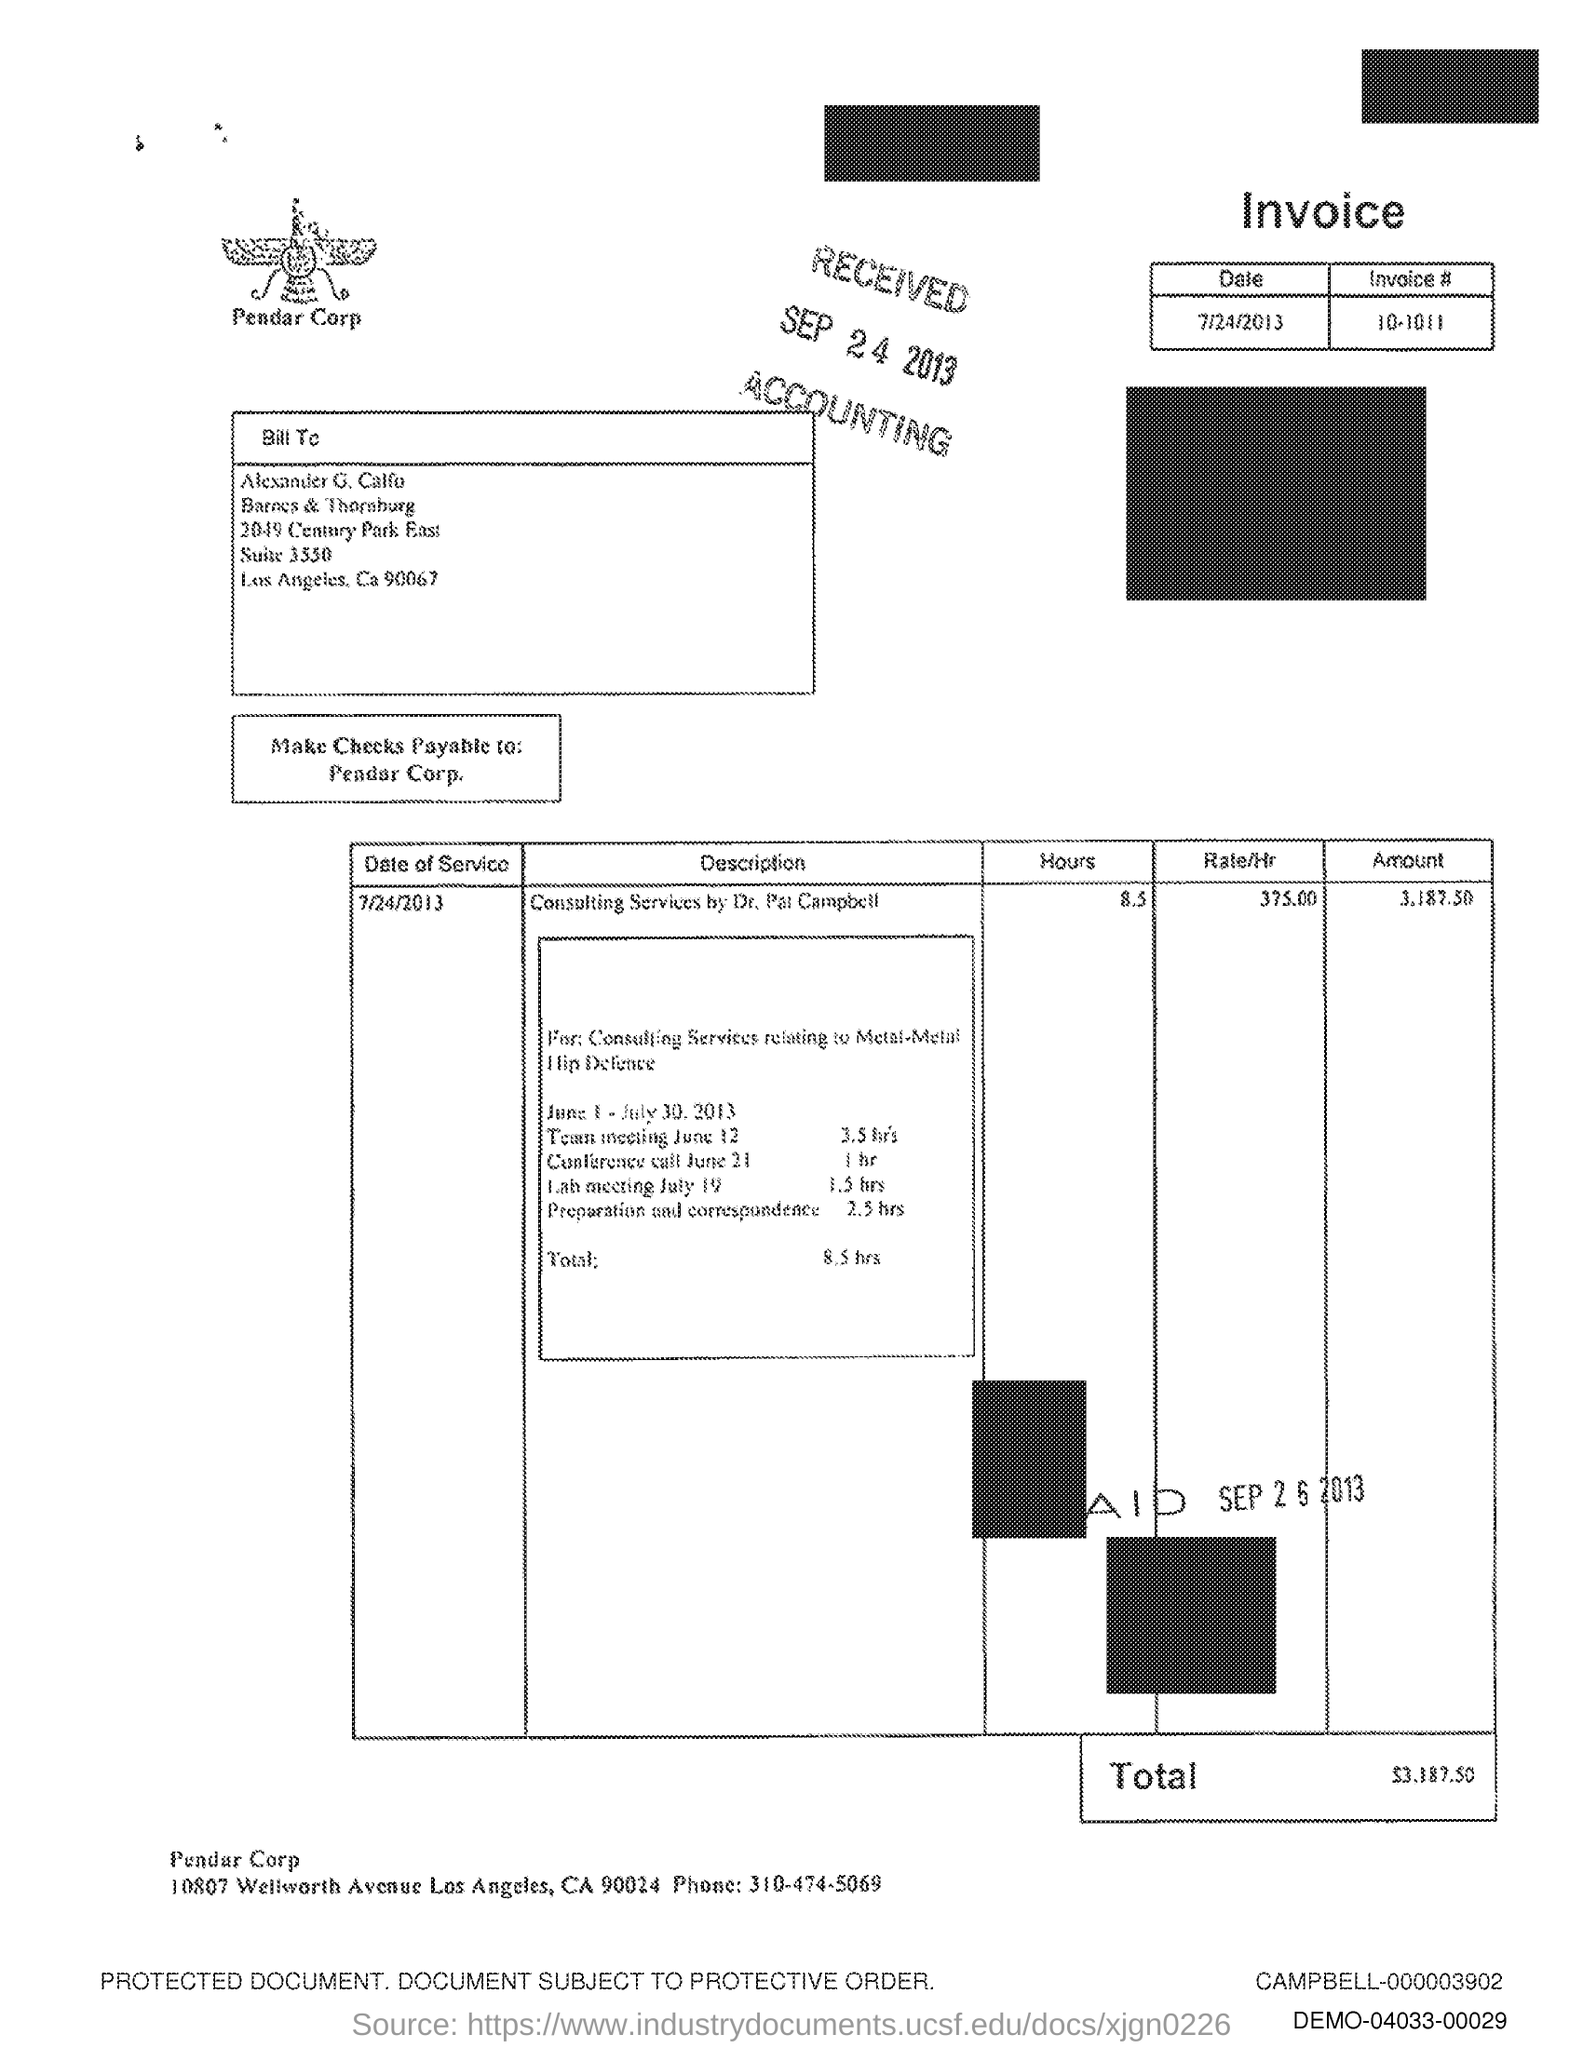Outline some significant characteristics in this image. The phone number is 310-474-5069. The text written below the image is 'PENDAR CORP.'. 